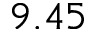<formula> <loc_0><loc_0><loc_500><loc_500>9 . 4 5</formula> 